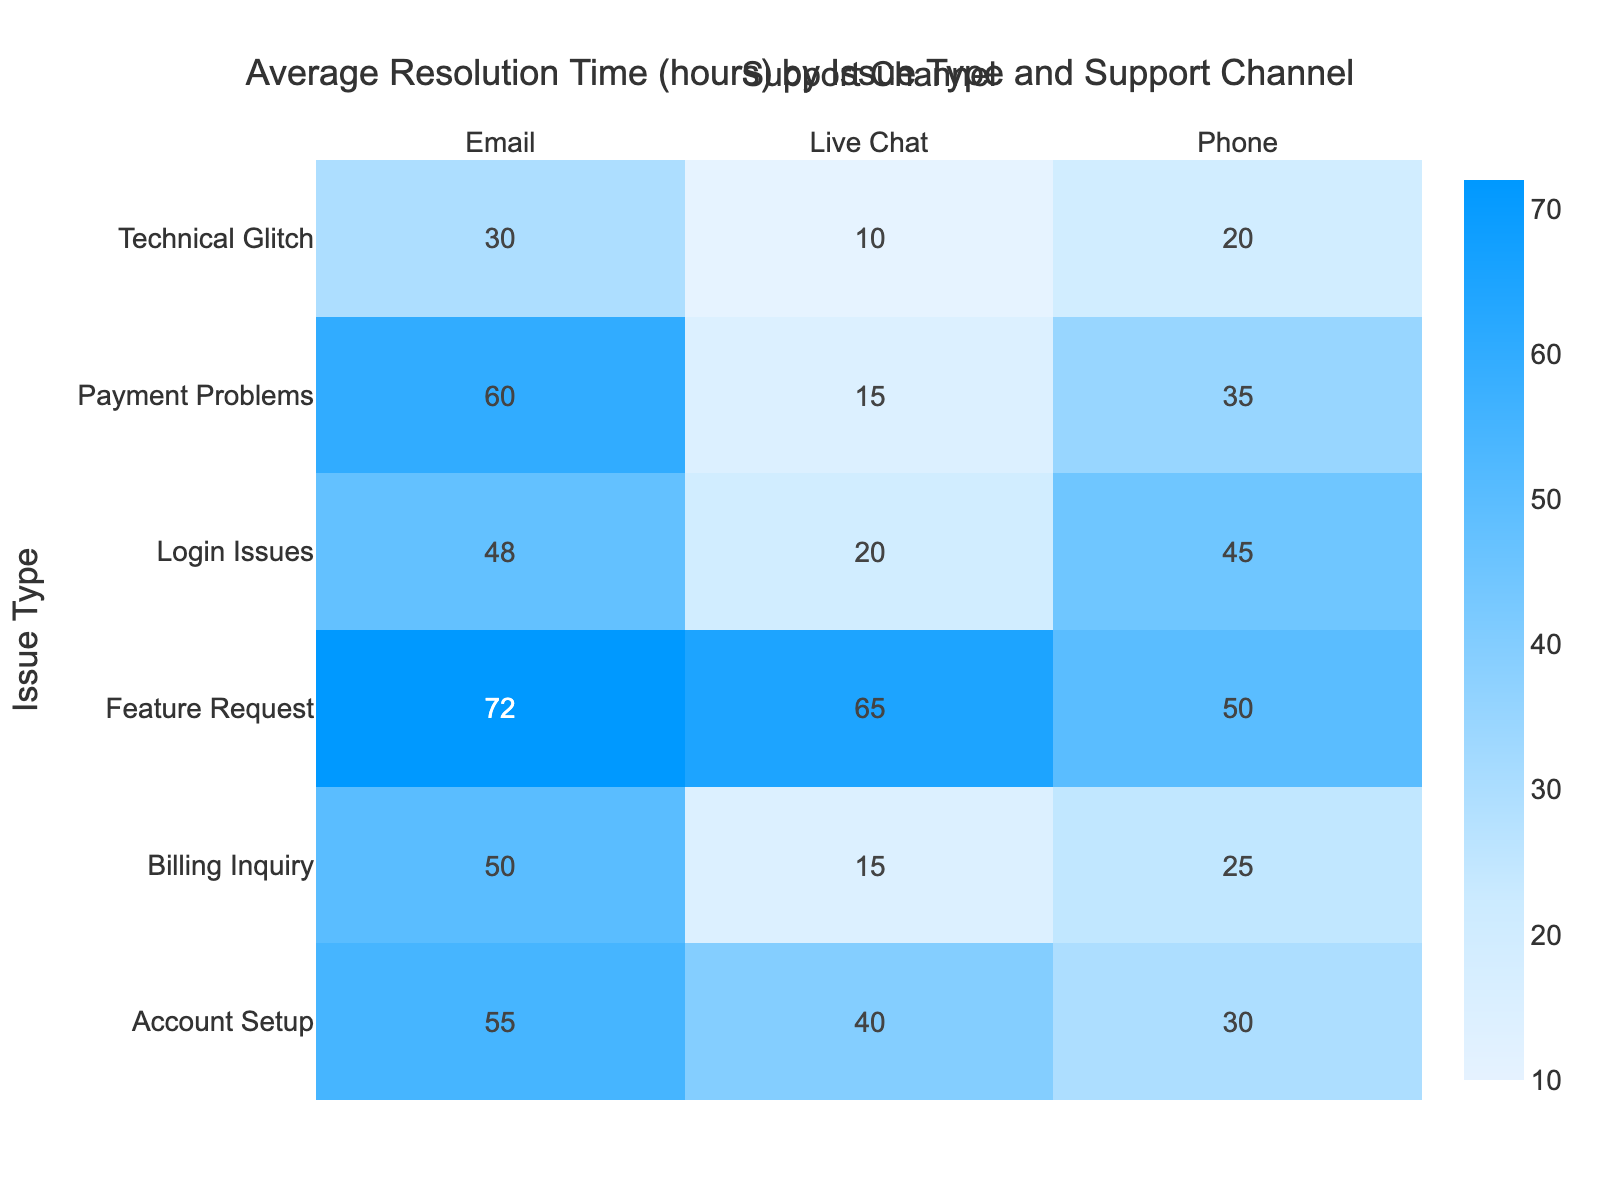What is the average resolution time for login issues via email? From the table, the resolution time for login issues via email is 48 hours.
Answer: 48 hours Which support channel has the fastest average resolution time for payment problems? The average resolution time for payment problems via live chat is 15 hours, which is less than email (60 hours) and phone (35 hours).
Answer: Live chat Is there a higher average resolution time for feature requests via phone or email? The average resolution time for feature requests via phone is 50 hours, while via email it is 72 hours. Since 72 is greater than 50, email has a higher average resolution time.
Answer: Yes, via email What is the average resolution time across all support channels for technical glitches? For technical glitches: live chat is 10 hours, email is 30 hours, and phone is 20 hours. The average is (10 + 30 + 20) / 3 = 60 / 3 = 20 hours.
Answer: 20 hours Which issue type has the highest average resolution time, and what is that time? Looking at the table: feature requests via email have the highest resolution time at 72 hours. Among all issue types, feature requests are the only with that maximum value.
Answer: Feature requests, 72 hours How much faster is the average resolution time for billing inquiries via live chat compared to via email? The average for billing inquiries via live chat is 15 hours, while via email it is 50 hours. The difference is 50 - 15 = 35 hours, meaning live chat is 35 hours faster.
Answer: 35 hours What is the total average resolution time across all support channels for account setup issues? For account setup: phone is 30 hours, live chat is 40 hours, and email is 55 hours. Average is (30 + 40 + 55) / 3 = 125 / 3 = approximately 41.7 hours.
Answer: Approximately 41.7 hours Do login issues have a longer average resolution time than billing inquiries when considering email and phone channels? For login issues: email is 48 hours and phone is 45 hours (average 46.5). For billing inquiries: email is 50 hours and phone is 25 hours (average 37.5). 46.5 is greater than 37.5.
Answer: Yes Is it true that the average resolution time for all issue types via live chat is below 30 hours? Checking the average resolution times via live chat: Technical Glitch (10), Payment Problems (15), Login Issues (20), Billing Inquiry (15), Account Setup (40), Feature Request (65). The average = (10 + 15 + 20 + 15 + 40 + 65) / 6 = 175 / 6 = approximately 29.2 hours. Since this value exceeds 30, it is false.
Answer: No 